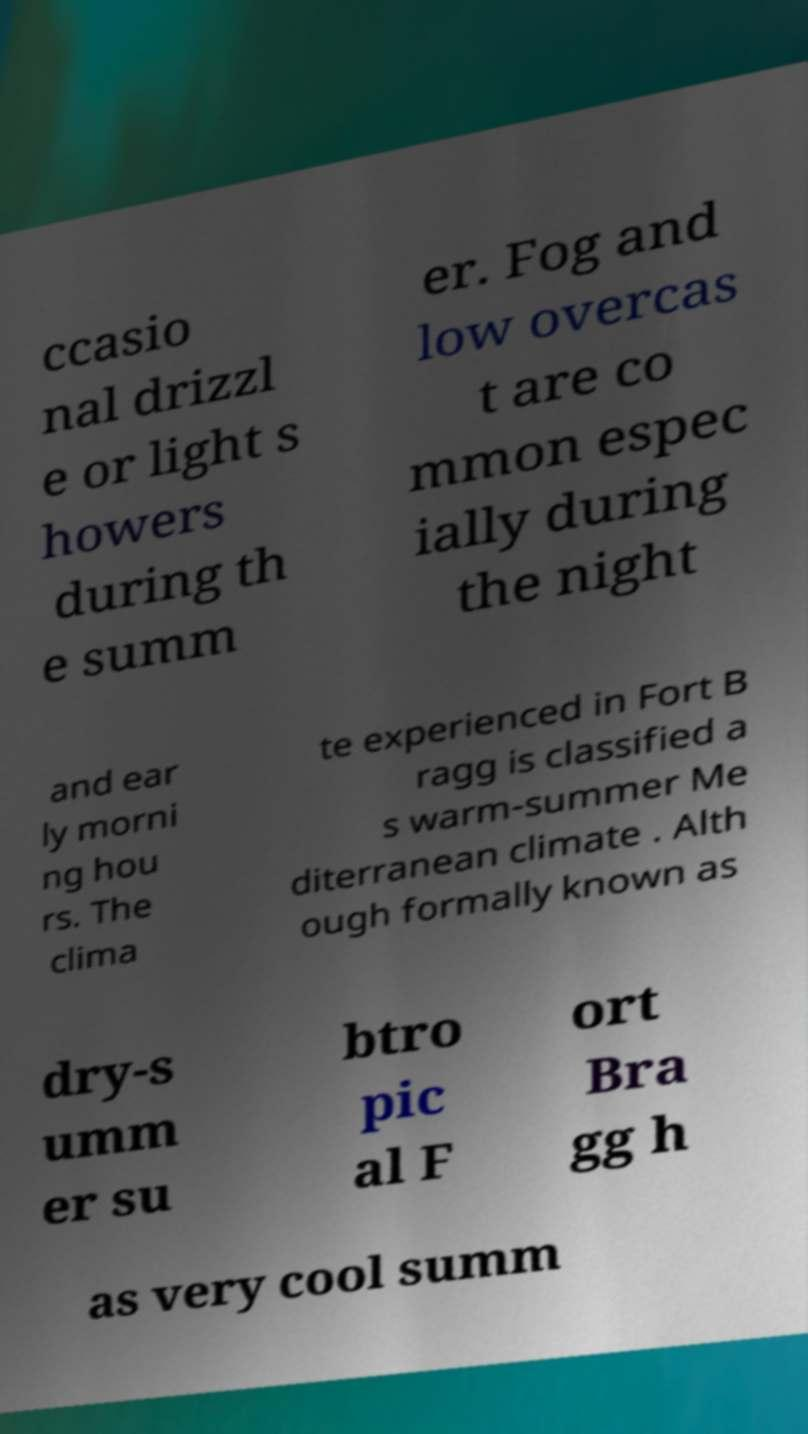What messages or text are displayed in this image? I need them in a readable, typed format. ccasio nal drizzl e or light s howers during th e summ er. Fog and low overcas t are co mmon espec ially during the night and ear ly morni ng hou rs. The clima te experienced in Fort B ragg is classified a s warm-summer Me diterranean climate . Alth ough formally known as dry-s umm er su btro pic al F ort Bra gg h as very cool summ 